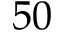<formula> <loc_0><loc_0><loc_500><loc_500>5 0</formula> 